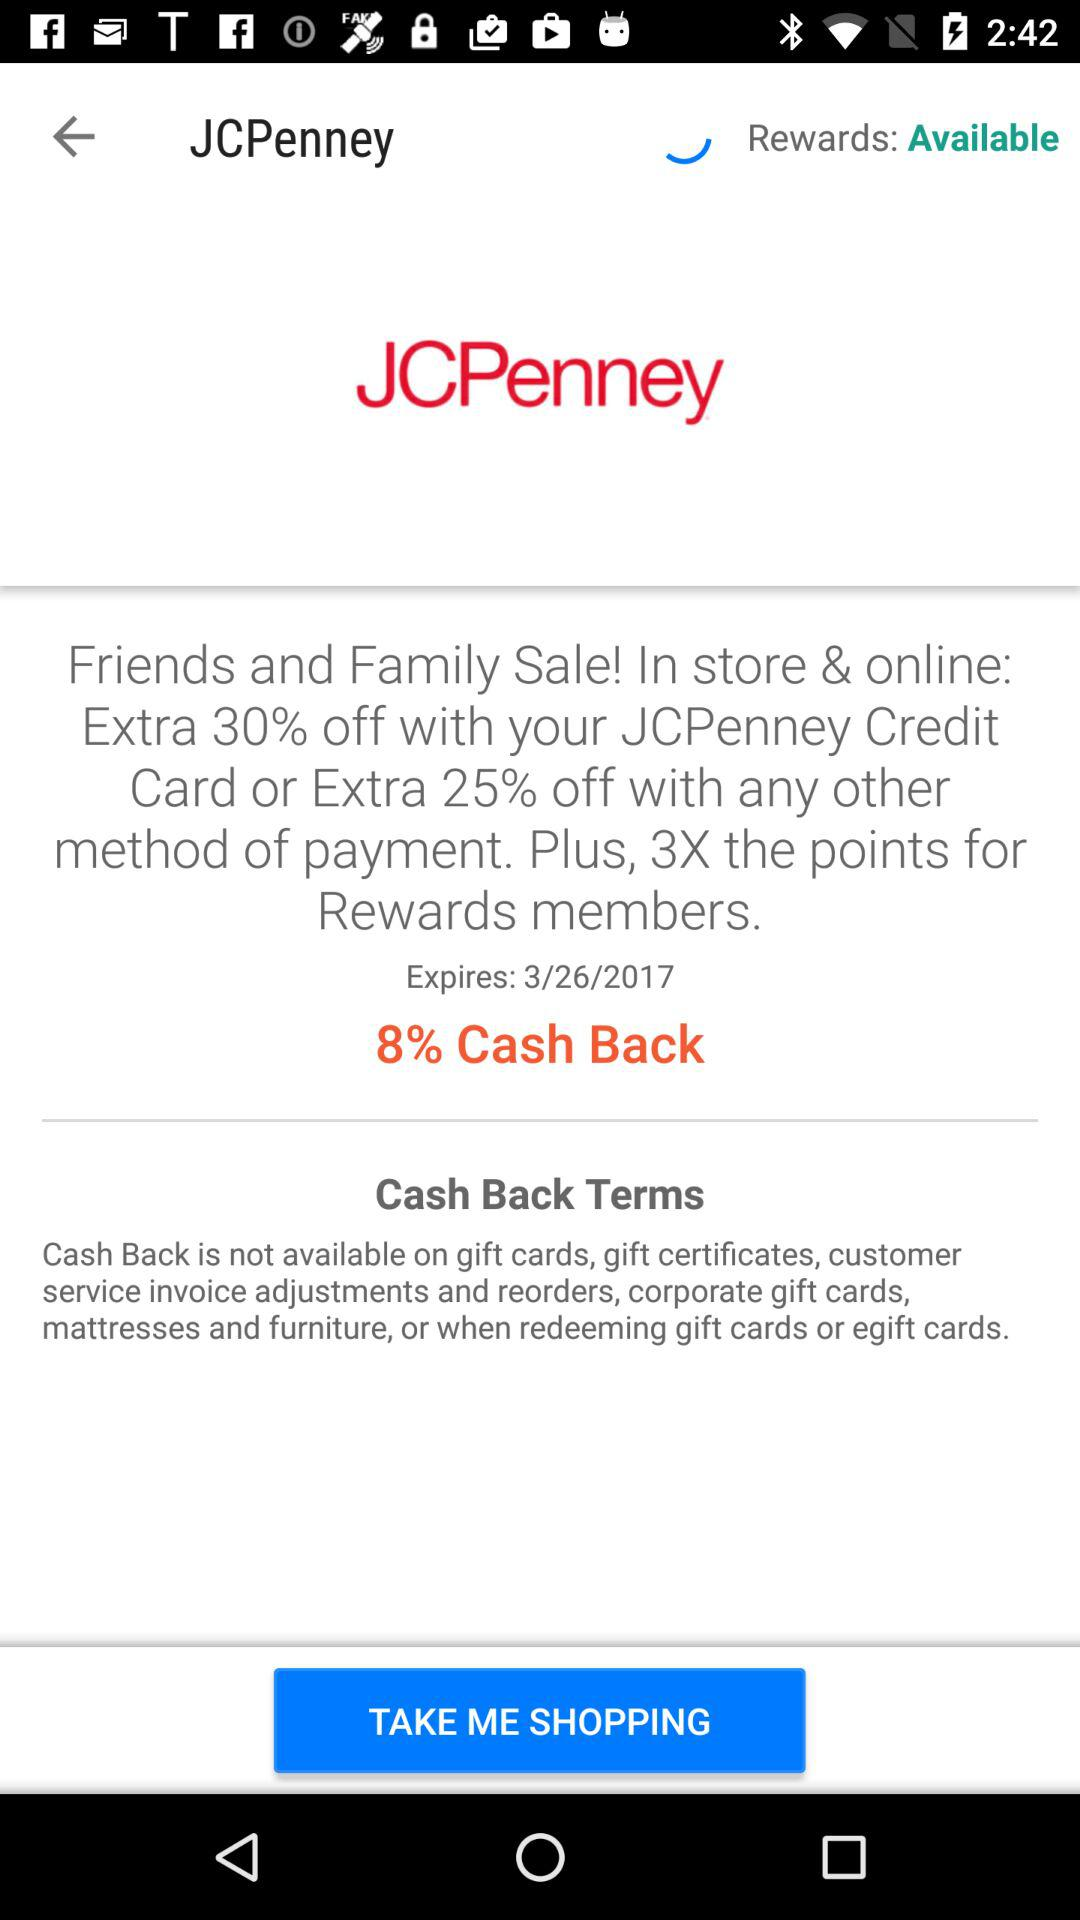How many more percentage points off do you get with the JCPenney credit card?
Answer the question using a single word or phrase. 5 